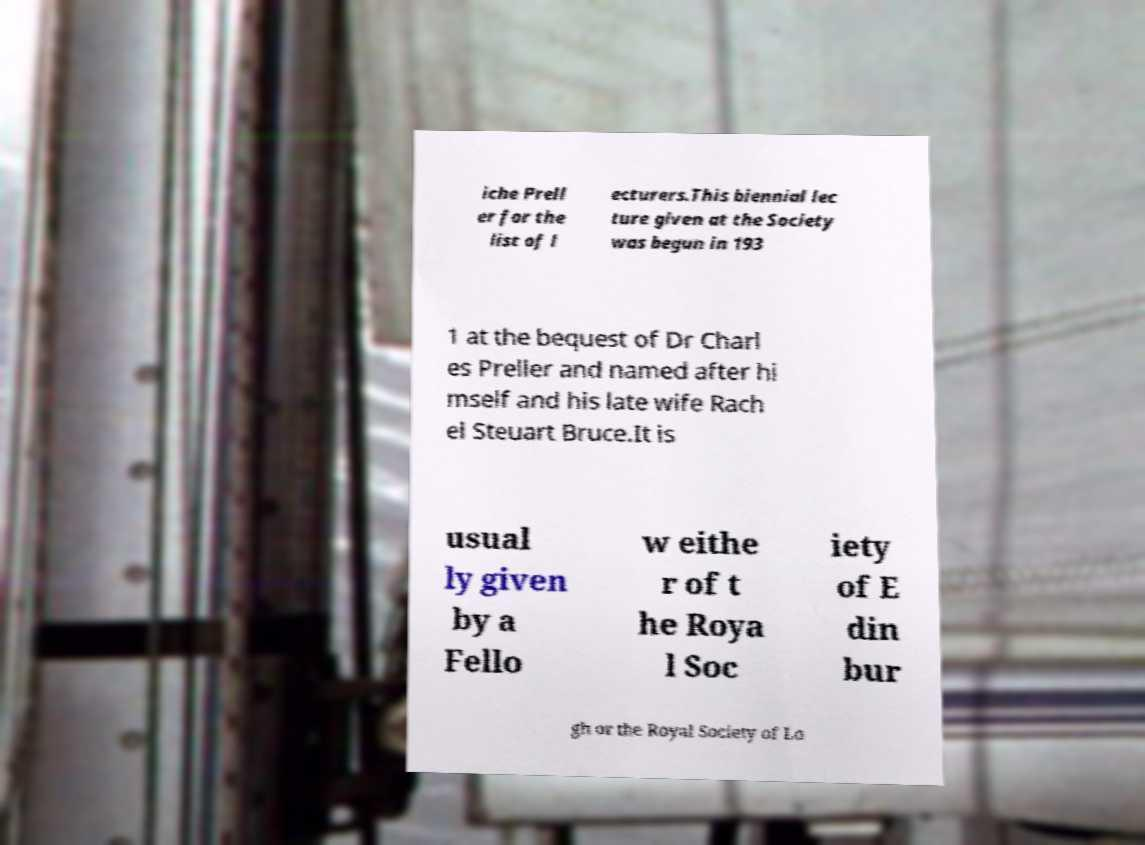Please read and relay the text visible in this image. What does it say? iche Prell er for the list of l ecturers.This biennial lec ture given at the Society was begun in 193 1 at the bequest of Dr Charl es Preller and named after hi mself and his late wife Rach el Steuart Bruce.It is usual ly given by a Fello w eithe r of t he Roya l Soc iety of E din bur gh or the Royal Society of Lo 